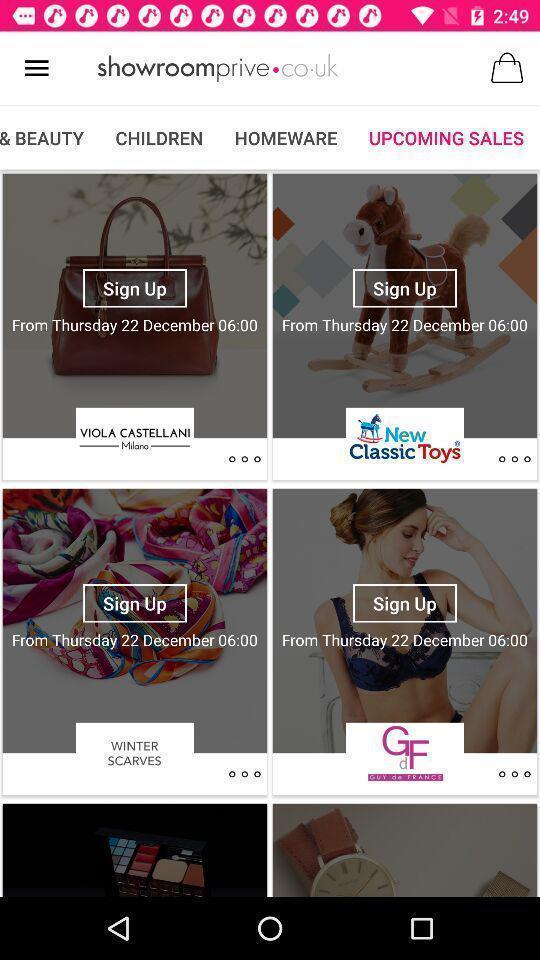What is the overall content of this screenshot? Various upcoming sale products displayed of a online shopping app. 